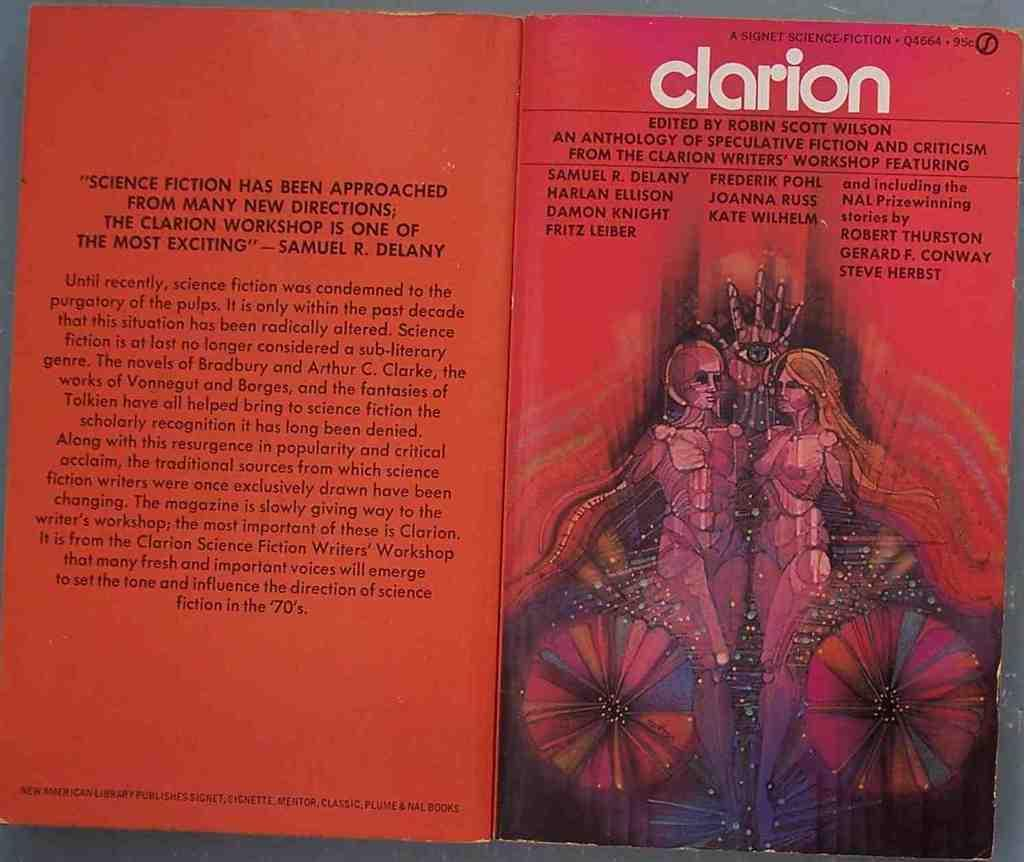<image>
Present a compact description of the photo's key features. a book open that has clarion on it 